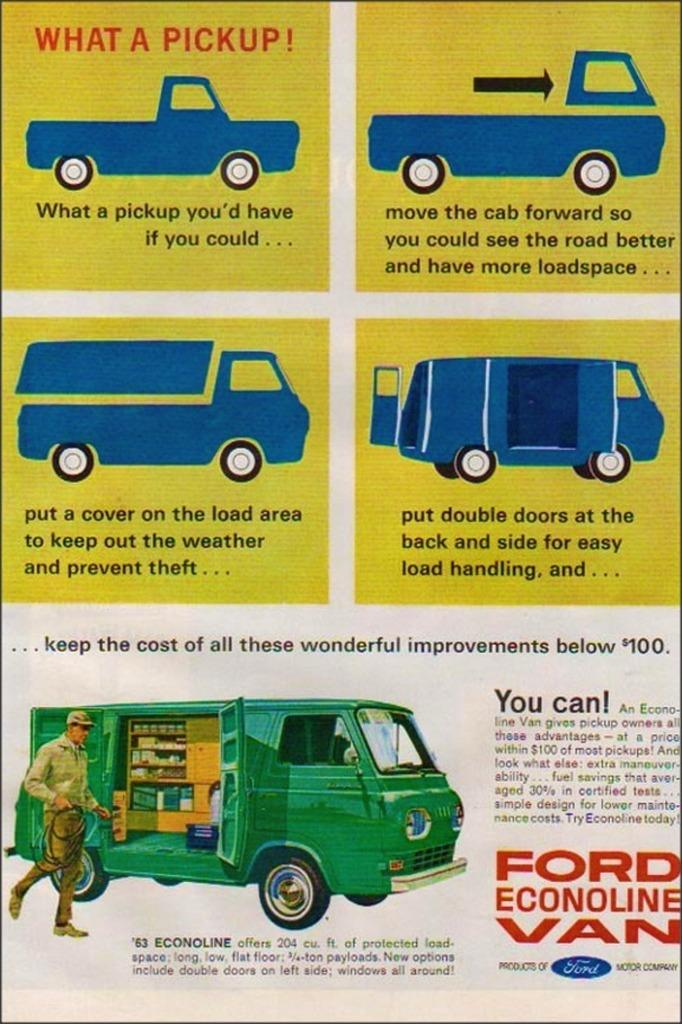What is the main subject of the poster in the image? The main subject of the poster in the image is trucks. Are there any other elements on the poster besides the images of trucks? Yes, there is text below the images on the poster. What type of cheese is being advertised on the poster? There is no cheese being advertised on the poster; it contains images of trucks and text. 